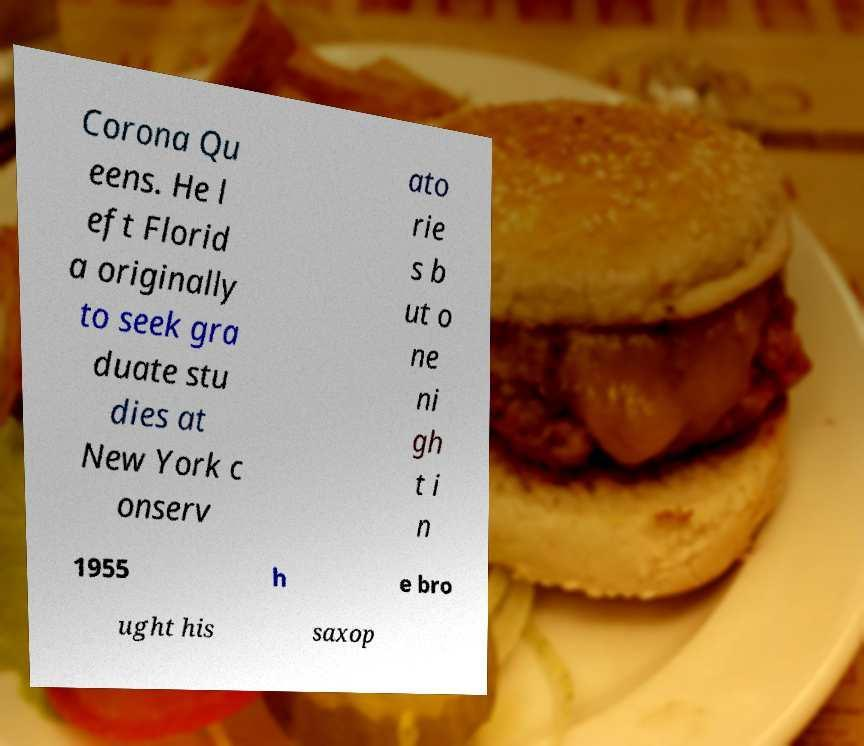Can you accurately transcribe the text from the provided image for me? Corona Qu eens. He l eft Florid a originally to seek gra duate stu dies at New York c onserv ato rie s b ut o ne ni gh t i n 1955 h e bro ught his saxop 